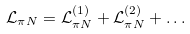<formula> <loc_0><loc_0><loc_500><loc_500>\mathcal { L } _ { \pi N } = \mathcal { L } _ { \pi N } ^ { ( 1 ) } + \mathcal { L } _ { \pi N } ^ { ( 2 ) } + \dots</formula> 